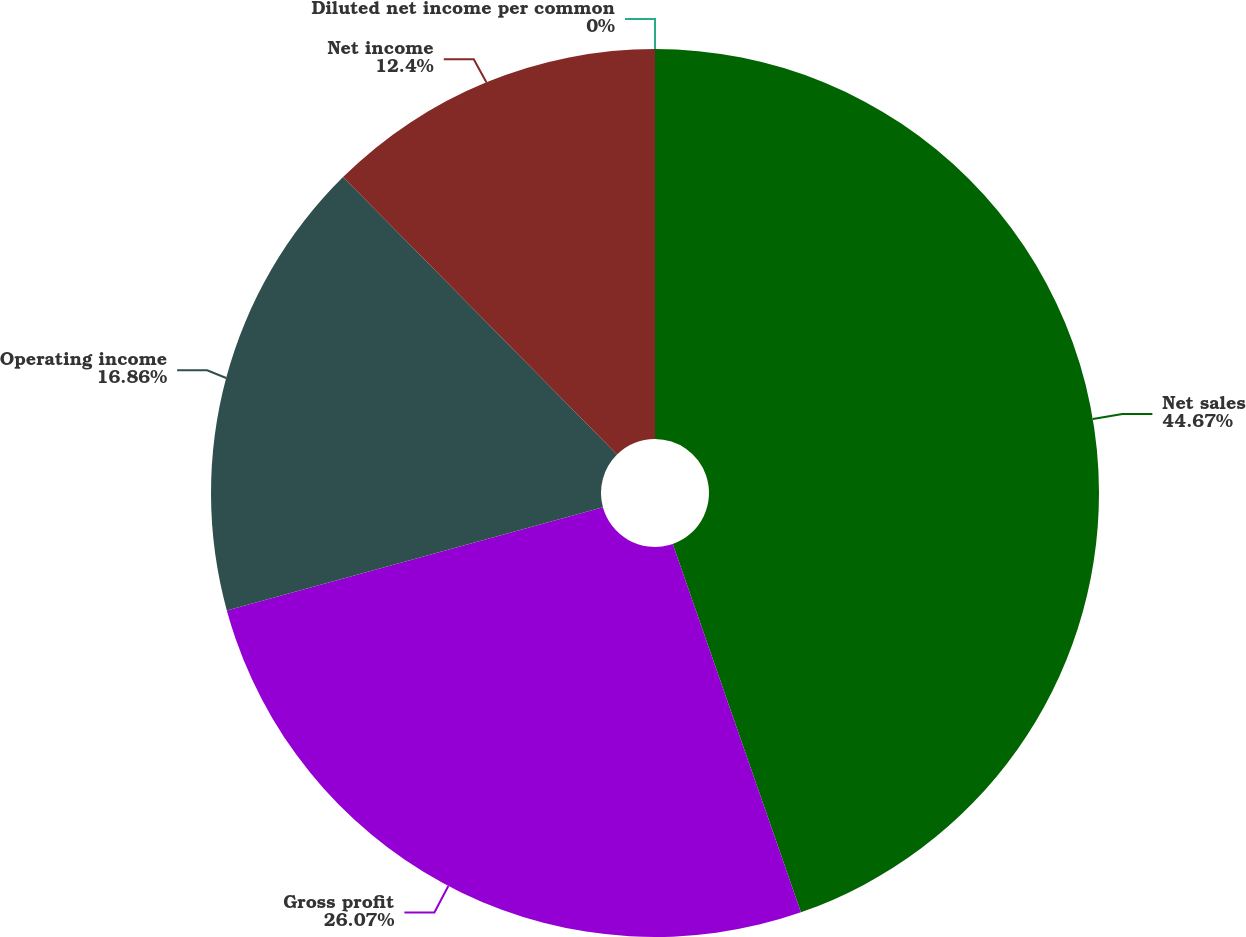<chart> <loc_0><loc_0><loc_500><loc_500><pie_chart><fcel>Net sales<fcel>Gross profit<fcel>Operating income<fcel>Net income<fcel>Diluted net income per common<nl><fcel>44.67%<fcel>26.07%<fcel>16.86%<fcel>12.4%<fcel>0.0%<nl></chart> 